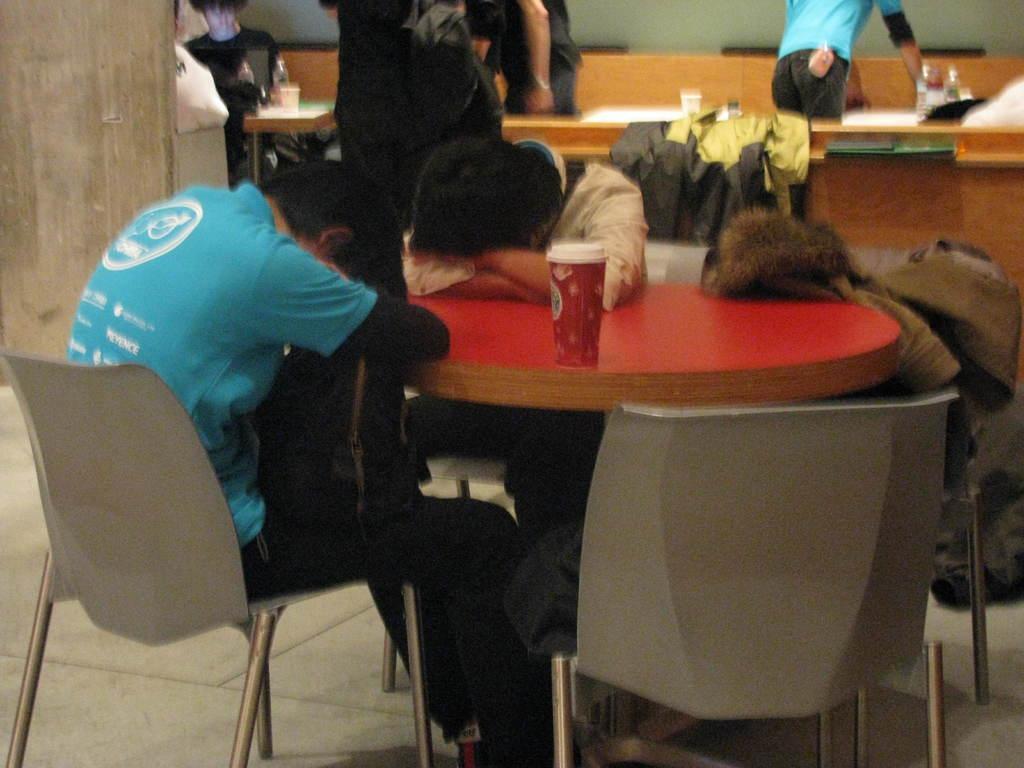Describe this image in one or two sentences. In this image there are three people lying on the table and sitting on the chairs. There is the tumbler on the table. In the background of the there are few people sitting and standing near the tables. There are few water bottles placed on the top of the table. 